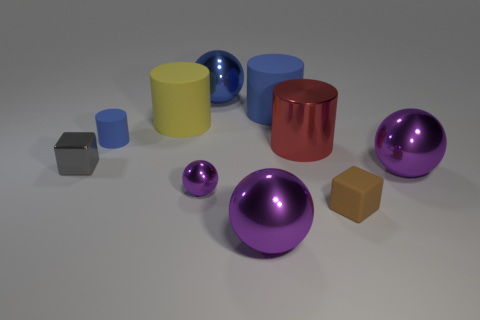Subtract all blue cylinders. How many purple spheres are left? 3 Subtract all cubes. How many objects are left? 8 Add 10 red metallic spheres. How many red metallic spheres exist? 10 Subtract 0 blue cubes. How many objects are left? 10 Subtract all brown things. Subtract all tiny cyan things. How many objects are left? 9 Add 6 small blue things. How many small blue things are left? 7 